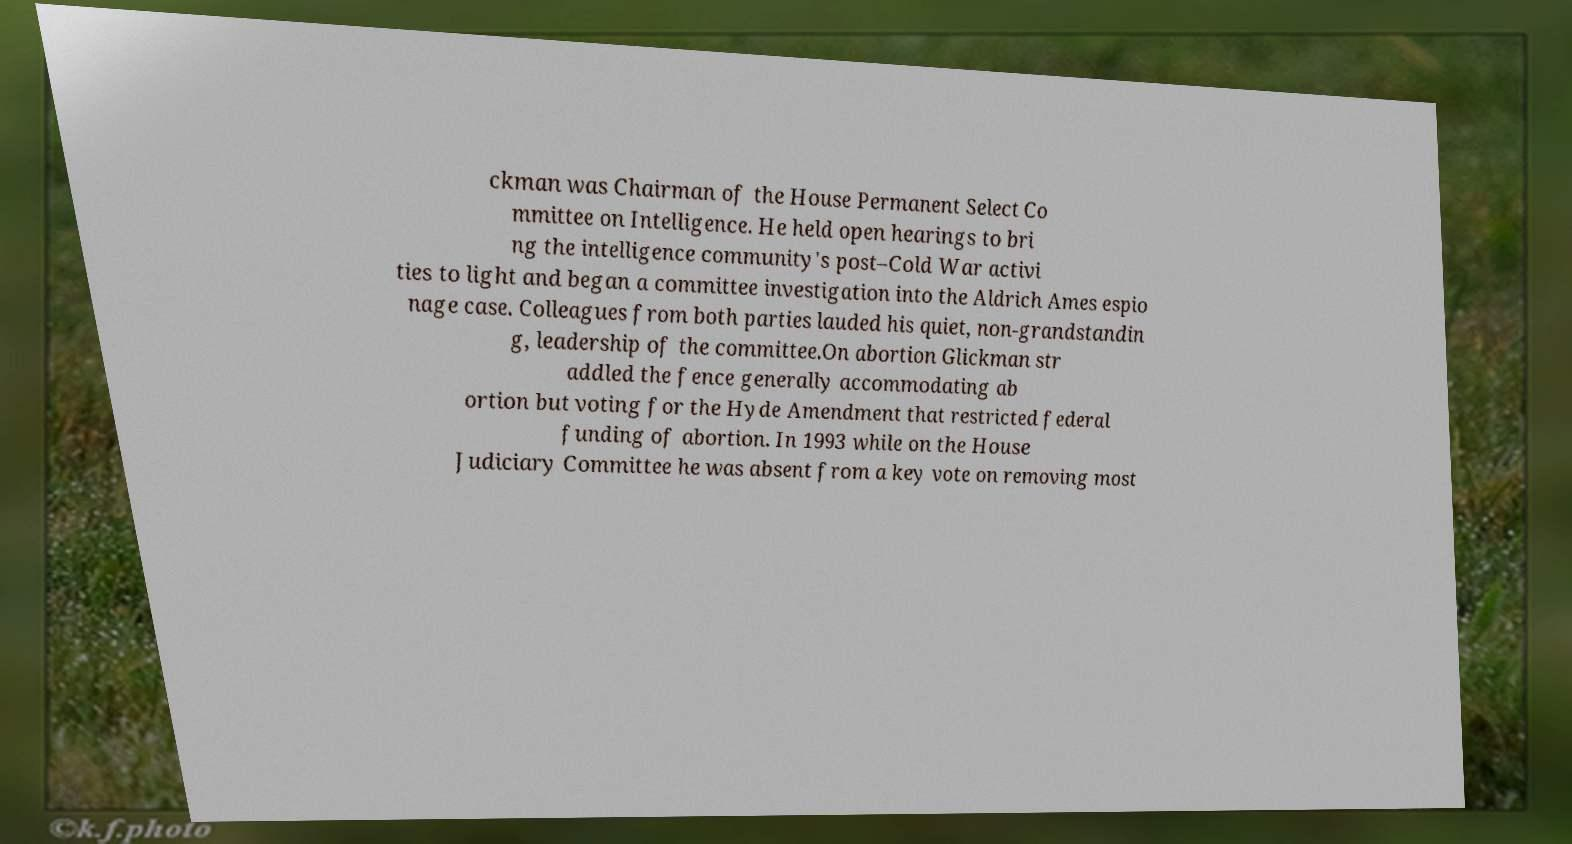Can you read and provide the text displayed in the image?This photo seems to have some interesting text. Can you extract and type it out for me? ckman was Chairman of the House Permanent Select Co mmittee on Intelligence. He held open hearings to bri ng the intelligence community's post–Cold War activi ties to light and began a committee investigation into the Aldrich Ames espio nage case. Colleagues from both parties lauded his quiet, non-grandstandin g, leadership of the committee.On abortion Glickman str addled the fence generally accommodating ab ortion but voting for the Hyde Amendment that restricted federal funding of abortion. In 1993 while on the House Judiciary Committee he was absent from a key vote on removing most 